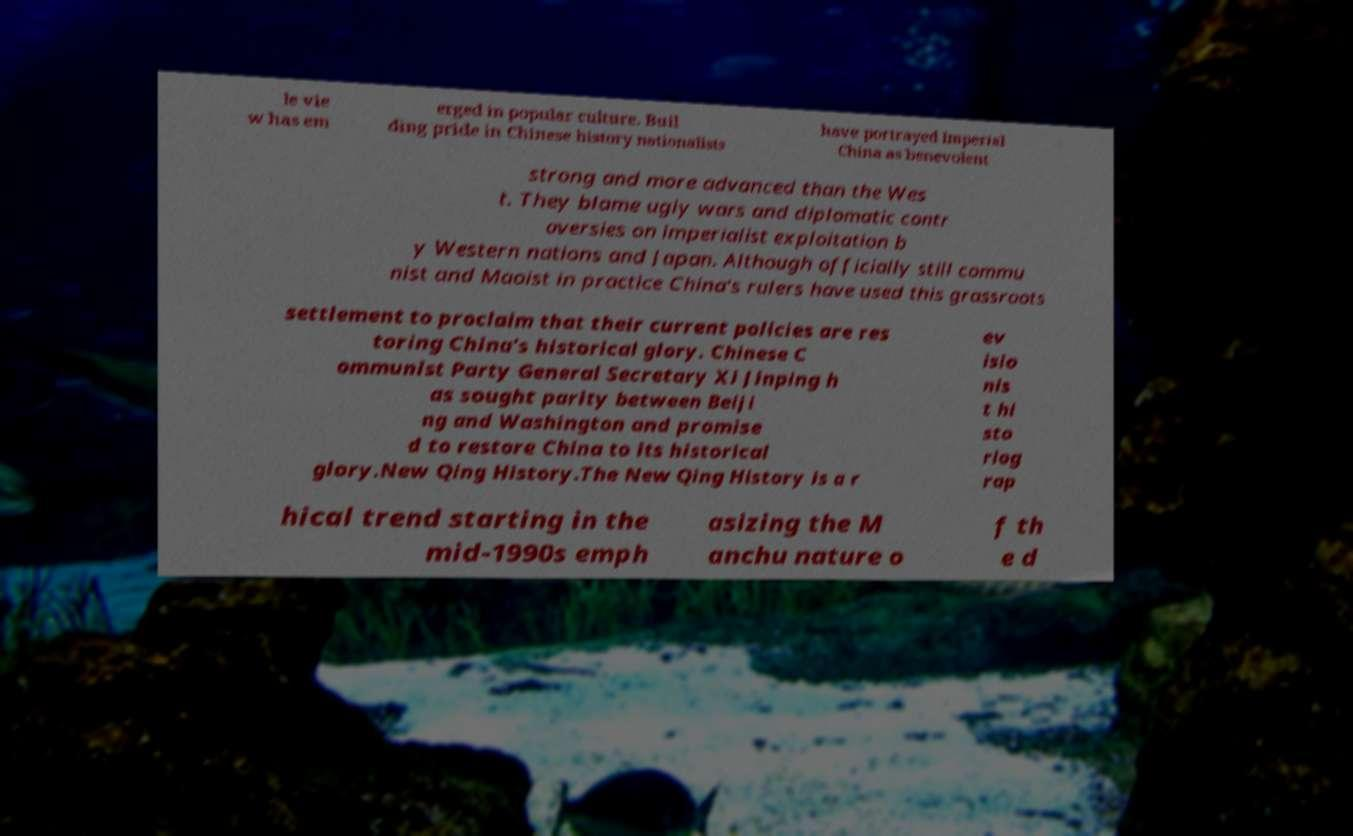Can you read and provide the text displayed in the image?This photo seems to have some interesting text. Can you extract and type it out for me? le vie w has em erged in popular culture. Buil ding pride in Chinese history nationalists have portrayed Imperial China as benevolent strong and more advanced than the Wes t. They blame ugly wars and diplomatic contr oversies on imperialist exploitation b y Western nations and Japan. Although officially still commu nist and Maoist in practice China's rulers have used this grassroots settlement to proclaim that their current policies are res toring China's historical glory. Chinese C ommunist Party General Secretary Xi Jinping h as sought parity between Beiji ng and Washington and promise d to restore China to its historical glory.New Qing History.The New Qing History is a r ev isio nis t hi sto riog rap hical trend starting in the mid-1990s emph asizing the M anchu nature o f th e d 